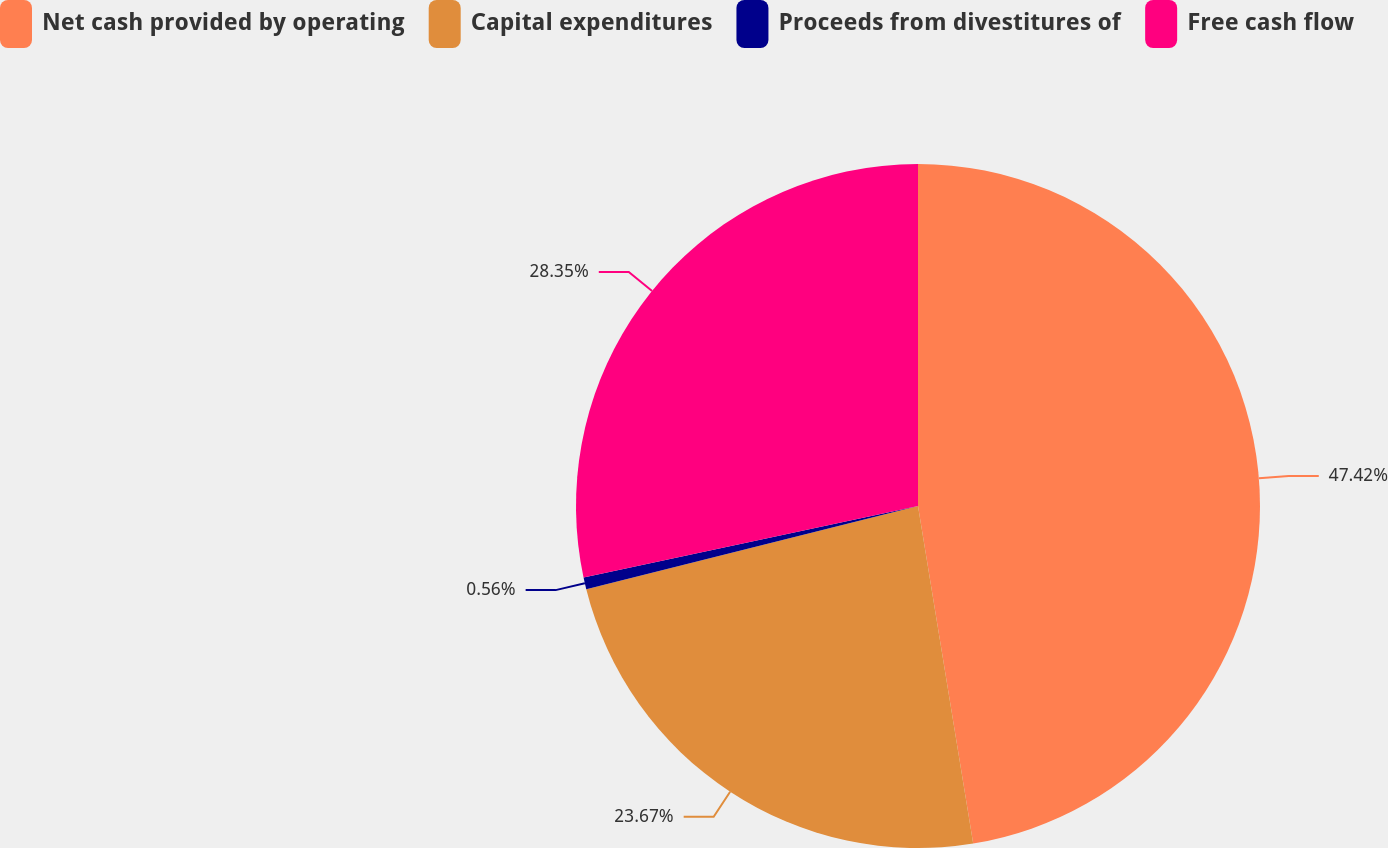Convert chart. <chart><loc_0><loc_0><loc_500><loc_500><pie_chart><fcel>Net cash provided by operating<fcel>Capital expenditures<fcel>Proceeds from divestitures of<fcel>Free cash flow<nl><fcel>47.42%<fcel>23.67%<fcel>0.56%<fcel>28.35%<nl></chart> 